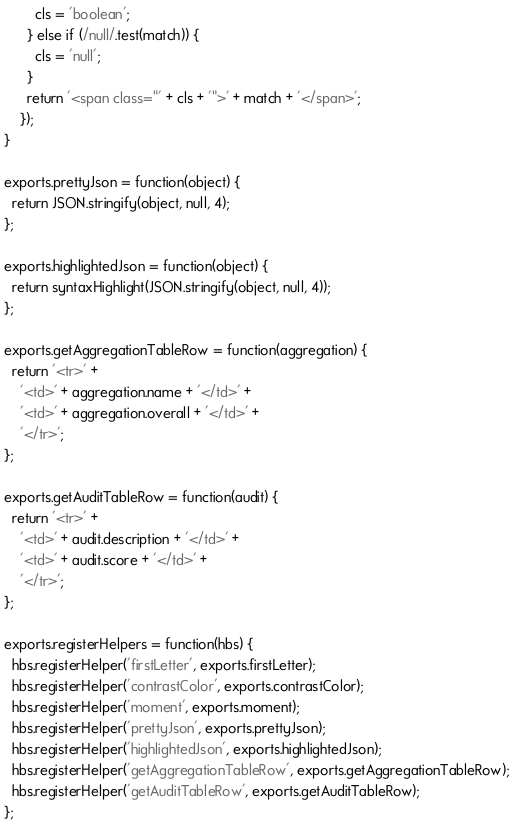<code> <loc_0><loc_0><loc_500><loc_500><_JavaScript_>        cls = 'boolean';
      } else if (/null/.test(match)) {
        cls = 'null';
      }
      return '<span class="' + cls + '">' + match + '</span>';
    });
}

exports.prettyJson = function(object) {
  return JSON.stringify(object, null, 4);
};

exports.highlightedJson = function(object) {
  return syntaxHighlight(JSON.stringify(object, null, 4));
};

exports.getAggregationTableRow = function(aggregation) {
  return '<tr>' +
    '<td>' + aggregation.name + '</td>' +
    '<td>' + aggregation.overall + '</td>' +
    '</tr>';
};

exports.getAuditTableRow = function(audit) {
  return '<tr>' +
    '<td>' + audit.description + '</td>' +
    '<td>' + audit.score + '</td>' +
    '</tr>';
};

exports.registerHelpers = function(hbs) {
  hbs.registerHelper('firstLetter', exports.firstLetter);
  hbs.registerHelper('contrastColor', exports.contrastColor);
  hbs.registerHelper('moment', exports.moment);
  hbs.registerHelper('prettyJson', exports.prettyJson);
  hbs.registerHelper('highlightedJson', exports.highlightedJson);
  hbs.registerHelper('getAggregationTableRow', exports.getAggregationTableRow);
  hbs.registerHelper('getAuditTableRow', exports.getAuditTableRow);
};
</code> 